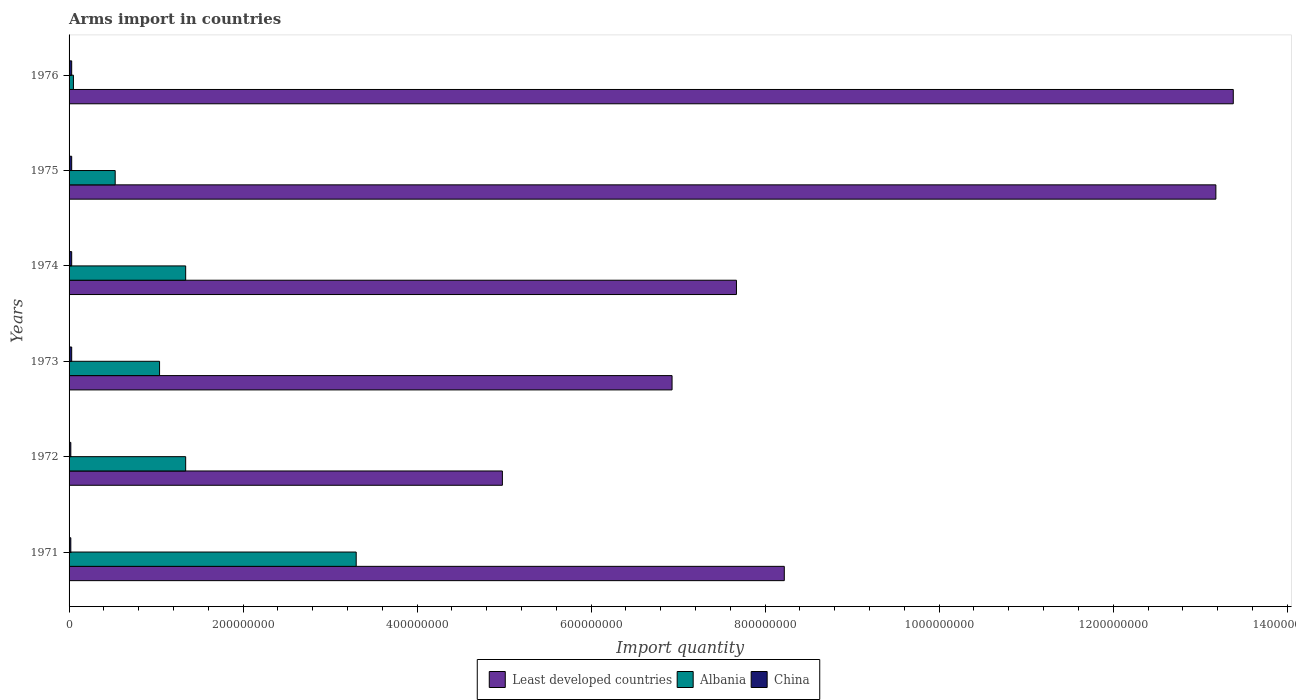Are the number of bars per tick equal to the number of legend labels?
Make the answer very short. Yes. How many bars are there on the 4th tick from the top?
Give a very brief answer. 3. How many bars are there on the 6th tick from the bottom?
Offer a very short reply. 3. What is the label of the 3rd group of bars from the top?
Offer a terse response. 1974. In how many cases, is the number of bars for a given year not equal to the number of legend labels?
Offer a very short reply. 0. What is the total arms import in Least developed countries in 1971?
Make the answer very short. 8.22e+08. Across all years, what is the maximum total arms import in Albania?
Keep it short and to the point. 3.30e+08. Across all years, what is the minimum total arms import in Albania?
Offer a terse response. 5.00e+06. In which year was the total arms import in China maximum?
Make the answer very short. 1973. In which year was the total arms import in Albania minimum?
Your answer should be very brief. 1976. What is the total total arms import in Least developed countries in the graph?
Provide a succinct answer. 5.44e+09. What is the difference between the total arms import in Least developed countries in 1971 and that in 1973?
Provide a succinct answer. 1.29e+08. What is the difference between the total arms import in Least developed countries in 1975 and the total arms import in China in 1974?
Offer a terse response. 1.32e+09. What is the average total arms import in Albania per year?
Ensure brevity in your answer.  1.27e+08. In the year 1971, what is the difference between the total arms import in China and total arms import in Albania?
Your answer should be compact. -3.28e+08. In how many years, is the total arms import in China greater than 1000000000 ?
Ensure brevity in your answer.  0. What is the ratio of the total arms import in Albania in 1972 to that in 1973?
Give a very brief answer. 1.29. What is the difference between the highest and the second highest total arms import in Albania?
Keep it short and to the point. 1.96e+08. What is the difference between the highest and the lowest total arms import in China?
Give a very brief answer. 1.00e+06. What does the 3rd bar from the top in 1976 represents?
Make the answer very short. Least developed countries. What does the 2nd bar from the bottom in 1974 represents?
Your answer should be compact. Albania. Is it the case that in every year, the sum of the total arms import in Least developed countries and total arms import in Albania is greater than the total arms import in China?
Keep it short and to the point. Yes. How many bars are there?
Offer a terse response. 18. Are all the bars in the graph horizontal?
Keep it short and to the point. Yes. What is the difference between two consecutive major ticks on the X-axis?
Provide a succinct answer. 2.00e+08. Does the graph contain any zero values?
Your answer should be compact. No. Does the graph contain grids?
Your answer should be compact. No. How many legend labels are there?
Ensure brevity in your answer.  3. What is the title of the graph?
Make the answer very short. Arms import in countries. What is the label or title of the X-axis?
Offer a terse response. Import quantity. What is the label or title of the Y-axis?
Offer a very short reply. Years. What is the Import quantity of Least developed countries in 1971?
Ensure brevity in your answer.  8.22e+08. What is the Import quantity of Albania in 1971?
Keep it short and to the point. 3.30e+08. What is the Import quantity of Least developed countries in 1972?
Give a very brief answer. 4.98e+08. What is the Import quantity of Albania in 1972?
Your response must be concise. 1.34e+08. What is the Import quantity of China in 1972?
Provide a short and direct response. 2.00e+06. What is the Import quantity of Least developed countries in 1973?
Provide a succinct answer. 6.93e+08. What is the Import quantity of Albania in 1973?
Provide a short and direct response. 1.04e+08. What is the Import quantity in China in 1973?
Keep it short and to the point. 3.00e+06. What is the Import quantity in Least developed countries in 1974?
Offer a very short reply. 7.67e+08. What is the Import quantity in Albania in 1974?
Offer a terse response. 1.34e+08. What is the Import quantity in Least developed countries in 1975?
Offer a terse response. 1.32e+09. What is the Import quantity of Albania in 1975?
Provide a short and direct response. 5.30e+07. What is the Import quantity in Least developed countries in 1976?
Your answer should be compact. 1.34e+09. What is the Import quantity in China in 1976?
Your answer should be very brief. 3.00e+06. Across all years, what is the maximum Import quantity of Least developed countries?
Your answer should be very brief. 1.34e+09. Across all years, what is the maximum Import quantity in Albania?
Your answer should be compact. 3.30e+08. Across all years, what is the minimum Import quantity of Least developed countries?
Your answer should be very brief. 4.98e+08. Across all years, what is the minimum Import quantity of Albania?
Make the answer very short. 5.00e+06. Across all years, what is the minimum Import quantity of China?
Your answer should be compact. 2.00e+06. What is the total Import quantity of Least developed countries in the graph?
Your response must be concise. 5.44e+09. What is the total Import quantity of Albania in the graph?
Give a very brief answer. 7.60e+08. What is the total Import quantity of China in the graph?
Provide a short and direct response. 1.60e+07. What is the difference between the Import quantity of Least developed countries in 1971 and that in 1972?
Make the answer very short. 3.24e+08. What is the difference between the Import quantity in Albania in 1971 and that in 1972?
Give a very brief answer. 1.96e+08. What is the difference between the Import quantity in Least developed countries in 1971 and that in 1973?
Ensure brevity in your answer.  1.29e+08. What is the difference between the Import quantity in Albania in 1971 and that in 1973?
Give a very brief answer. 2.26e+08. What is the difference between the Import quantity of Least developed countries in 1971 and that in 1974?
Offer a terse response. 5.50e+07. What is the difference between the Import quantity of Albania in 1971 and that in 1974?
Give a very brief answer. 1.96e+08. What is the difference between the Import quantity in Least developed countries in 1971 and that in 1975?
Your answer should be very brief. -4.96e+08. What is the difference between the Import quantity of Albania in 1971 and that in 1975?
Provide a succinct answer. 2.77e+08. What is the difference between the Import quantity in Least developed countries in 1971 and that in 1976?
Provide a short and direct response. -5.16e+08. What is the difference between the Import quantity of Albania in 1971 and that in 1976?
Keep it short and to the point. 3.25e+08. What is the difference between the Import quantity of Least developed countries in 1972 and that in 1973?
Ensure brevity in your answer.  -1.95e+08. What is the difference between the Import quantity in Albania in 1972 and that in 1973?
Make the answer very short. 3.00e+07. What is the difference between the Import quantity of China in 1972 and that in 1973?
Keep it short and to the point. -1.00e+06. What is the difference between the Import quantity of Least developed countries in 1972 and that in 1974?
Keep it short and to the point. -2.69e+08. What is the difference between the Import quantity of Albania in 1972 and that in 1974?
Provide a succinct answer. 0. What is the difference between the Import quantity of China in 1972 and that in 1974?
Your answer should be very brief. -1.00e+06. What is the difference between the Import quantity in Least developed countries in 1972 and that in 1975?
Provide a short and direct response. -8.20e+08. What is the difference between the Import quantity of Albania in 1972 and that in 1975?
Your response must be concise. 8.10e+07. What is the difference between the Import quantity of Least developed countries in 1972 and that in 1976?
Give a very brief answer. -8.40e+08. What is the difference between the Import quantity of Albania in 1972 and that in 1976?
Your response must be concise. 1.29e+08. What is the difference between the Import quantity in China in 1972 and that in 1976?
Provide a short and direct response. -1.00e+06. What is the difference between the Import quantity in Least developed countries in 1973 and that in 1974?
Ensure brevity in your answer.  -7.40e+07. What is the difference between the Import quantity in Albania in 1973 and that in 1974?
Your answer should be very brief. -3.00e+07. What is the difference between the Import quantity in China in 1973 and that in 1974?
Your answer should be compact. 0. What is the difference between the Import quantity of Least developed countries in 1973 and that in 1975?
Give a very brief answer. -6.25e+08. What is the difference between the Import quantity of Albania in 1973 and that in 1975?
Keep it short and to the point. 5.10e+07. What is the difference between the Import quantity in China in 1973 and that in 1975?
Ensure brevity in your answer.  0. What is the difference between the Import quantity in Least developed countries in 1973 and that in 1976?
Your response must be concise. -6.45e+08. What is the difference between the Import quantity in Albania in 1973 and that in 1976?
Offer a very short reply. 9.90e+07. What is the difference between the Import quantity in Least developed countries in 1974 and that in 1975?
Your answer should be compact. -5.51e+08. What is the difference between the Import quantity in Albania in 1974 and that in 1975?
Your response must be concise. 8.10e+07. What is the difference between the Import quantity of China in 1974 and that in 1975?
Provide a short and direct response. 0. What is the difference between the Import quantity in Least developed countries in 1974 and that in 1976?
Keep it short and to the point. -5.71e+08. What is the difference between the Import quantity of Albania in 1974 and that in 1976?
Make the answer very short. 1.29e+08. What is the difference between the Import quantity in China in 1974 and that in 1976?
Provide a short and direct response. 0. What is the difference between the Import quantity in Least developed countries in 1975 and that in 1976?
Offer a terse response. -2.00e+07. What is the difference between the Import quantity of Albania in 1975 and that in 1976?
Make the answer very short. 4.80e+07. What is the difference between the Import quantity in Least developed countries in 1971 and the Import quantity in Albania in 1972?
Provide a short and direct response. 6.88e+08. What is the difference between the Import quantity in Least developed countries in 1971 and the Import quantity in China in 1972?
Your answer should be very brief. 8.20e+08. What is the difference between the Import quantity in Albania in 1971 and the Import quantity in China in 1972?
Keep it short and to the point. 3.28e+08. What is the difference between the Import quantity in Least developed countries in 1971 and the Import quantity in Albania in 1973?
Your answer should be compact. 7.18e+08. What is the difference between the Import quantity of Least developed countries in 1971 and the Import quantity of China in 1973?
Provide a succinct answer. 8.19e+08. What is the difference between the Import quantity in Albania in 1971 and the Import quantity in China in 1973?
Give a very brief answer. 3.27e+08. What is the difference between the Import quantity of Least developed countries in 1971 and the Import quantity of Albania in 1974?
Your answer should be compact. 6.88e+08. What is the difference between the Import quantity in Least developed countries in 1971 and the Import quantity in China in 1974?
Ensure brevity in your answer.  8.19e+08. What is the difference between the Import quantity of Albania in 1971 and the Import quantity of China in 1974?
Make the answer very short. 3.27e+08. What is the difference between the Import quantity of Least developed countries in 1971 and the Import quantity of Albania in 1975?
Your answer should be very brief. 7.69e+08. What is the difference between the Import quantity of Least developed countries in 1971 and the Import quantity of China in 1975?
Ensure brevity in your answer.  8.19e+08. What is the difference between the Import quantity in Albania in 1971 and the Import quantity in China in 1975?
Provide a succinct answer. 3.27e+08. What is the difference between the Import quantity of Least developed countries in 1971 and the Import quantity of Albania in 1976?
Offer a very short reply. 8.17e+08. What is the difference between the Import quantity in Least developed countries in 1971 and the Import quantity in China in 1976?
Make the answer very short. 8.19e+08. What is the difference between the Import quantity in Albania in 1971 and the Import quantity in China in 1976?
Your answer should be compact. 3.27e+08. What is the difference between the Import quantity in Least developed countries in 1972 and the Import quantity in Albania in 1973?
Offer a terse response. 3.94e+08. What is the difference between the Import quantity in Least developed countries in 1972 and the Import quantity in China in 1973?
Your answer should be very brief. 4.95e+08. What is the difference between the Import quantity of Albania in 1972 and the Import quantity of China in 1973?
Ensure brevity in your answer.  1.31e+08. What is the difference between the Import quantity of Least developed countries in 1972 and the Import quantity of Albania in 1974?
Your answer should be compact. 3.64e+08. What is the difference between the Import quantity of Least developed countries in 1972 and the Import quantity of China in 1974?
Your answer should be very brief. 4.95e+08. What is the difference between the Import quantity of Albania in 1972 and the Import quantity of China in 1974?
Provide a succinct answer. 1.31e+08. What is the difference between the Import quantity in Least developed countries in 1972 and the Import quantity in Albania in 1975?
Your answer should be compact. 4.45e+08. What is the difference between the Import quantity in Least developed countries in 1972 and the Import quantity in China in 1975?
Provide a succinct answer. 4.95e+08. What is the difference between the Import quantity of Albania in 1972 and the Import quantity of China in 1975?
Keep it short and to the point. 1.31e+08. What is the difference between the Import quantity in Least developed countries in 1972 and the Import quantity in Albania in 1976?
Your response must be concise. 4.93e+08. What is the difference between the Import quantity of Least developed countries in 1972 and the Import quantity of China in 1976?
Offer a very short reply. 4.95e+08. What is the difference between the Import quantity of Albania in 1972 and the Import quantity of China in 1976?
Your response must be concise. 1.31e+08. What is the difference between the Import quantity in Least developed countries in 1973 and the Import quantity in Albania in 1974?
Make the answer very short. 5.59e+08. What is the difference between the Import quantity in Least developed countries in 1973 and the Import quantity in China in 1974?
Offer a very short reply. 6.90e+08. What is the difference between the Import quantity in Albania in 1973 and the Import quantity in China in 1974?
Offer a terse response. 1.01e+08. What is the difference between the Import quantity in Least developed countries in 1973 and the Import quantity in Albania in 1975?
Make the answer very short. 6.40e+08. What is the difference between the Import quantity in Least developed countries in 1973 and the Import quantity in China in 1975?
Provide a succinct answer. 6.90e+08. What is the difference between the Import quantity in Albania in 1973 and the Import quantity in China in 1975?
Your answer should be compact. 1.01e+08. What is the difference between the Import quantity in Least developed countries in 1973 and the Import quantity in Albania in 1976?
Provide a succinct answer. 6.88e+08. What is the difference between the Import quantity of Least developed countries in 1973 and the Import quantity of China in 1976?
Your answer should be compact. 6.90e+08. What is the difference between the Import quantity in Albania in 1973 and the Import quantity in China in 1976?
Your answer should be very brief. 1.01e+08. What is the difference between the Import quantity in Least developed countries in 1974 and the Import quantity in Albania in 1975?
Provide a succinct answer. 7.14e+08. What is the difference between the Import quantity in Least developed countries in 1974 and the Import quantity in China in 1975?
Offer a very short reply. 7.64e+08. What is the difference between the Import quantity of Albania in 1974 and the Import quantity of China in 1975?
Provide a succinct answer. 1.31e+08. What is the difference between the Import quantity of Least developed countries in 1974 and the Import quantity of Albania in 1976?
Your answer should be compact. 7.62e+08. What is the difference between the Import quantity of Least developed countries in 1974 and the Import quantity of China in 1976?
Your answer should be very brief. 7.64e+08. What is the difference between the Import quantity in Albania in 1974 and the Import quantity in China in 1976?
Keep it short and to the point. 1.31e+08. What is the difference between the Import quantity in Least developed countries in 1975 and the Import quantity in Albania in 1976?
Ensure brevity in your answer.  1.31e+09. What is the difference between the Import quantity in Least developed countries in 1975 and the Import quantity in China in 1976?
Offer a very short reply. 1.32e+09. What is the average Import quantity in Least developed countries per year?
Your answer should be very brief. 9.06e+08. What is the average Import quantity of Albania per year?
Offer a very short reply. 1.27e+08. What is the average Import quantity of China per year?
Ensure brevity in your answer.  2.67e+06. In the year 1971, what is the difference between the Import quantity of Least developed countries and Import quantity of Albania?
Offer a very short reply. 4.92e+08. In the year 1971, what is the difference between the Import quantity of Least developed countries and Import quantity of China?
Your response must be concise. 8.20e+08. In the year 1971, what is the difference between the Import quantity of Albania and Import quantity of China?
Your answer should be very brief. 3.28e+08. In the year 1972, what is the difference between the Import quantity of Least developed countries and Import quantity of Albania?
Your answer should be very brief. 3.64e+08. In the year 1972, what is the difference between the Import quantity in Least developed countries and Import quantity in China?
Ensure brevity in your answer.  4.96e+08. In the year 1972, what is the difference between the Import quantity of Albania and Import quantity of China?
Ensure brevity in your answer.  1.32e+08. In the year 1973, what is the difference between the Import quantity of Least developed countries and Import quantity of Albania?
Offer a terse response. 5.89e+08. In the year 1973, what is the difference between the Import quantity of Least developed countries and Import quantity of China?
Ensure brevity in your answer.  6.90e+08. In the year 1973, what is the difference between the Import quantity in Albania and Import quantity in China?
Offer a very short reply. 1.01e+08. In the year 1974, what is the difference between the Import quantity in Least developed countries and Import quantity in Albania?
Ensure brevity in your answer.  6.33e+08. In the year 1974, what is the difference between the Import quantity in Least developed countries and Import quantity in China?
Your answer should be compact. 7.64e+08. In the year 1974, what is the difference between the Import quantity in Albania and Import quantity in China?
Offer a terse response. 1.31e+08. In the year 1975, what is the difference between the Import quantity of Least developed countries and Import quantity of Albania?
Provide a short and direct response. 1.26e+09. In the year 1975, what is the difference between the Import quantity in Least developed countries and Import quantity in China?
Keep it short and to the point. 1.32e+09. In the year 1976, what is the difference between the Import quantity of Least developed countries and Import quantity of Albania?
Provide a succinct answer. 1.33e+09. In the year 1976, what is the difference between the Import quantity in Least developed countries and Import quantity in China?
Provide a short and direct response. 1.34e+09. In the year 1976, what is the difference between the Import quantity of Albania and Import quantity of China?
Make the answer very short. 2.00e+06. What is the ratio of the Import quantity in Least developed countries in 1971 to that in 1972?
Provide a succinct answer. 1.65. What is the ratio of the Import quantity of Albania in 1971 to that in 1972?
Keep it short and to the point. 2.46. What is the ratio of the Import quantity in China in 1971 to that in 1972?
Ensure brevity in your answer.  1. What is the ratio of the Import quantity in Least developed countries in 1971 to that in 1973?
Provide a short and direct response. 1.19. What is the ratio of the Import quantity in Albania in 1971 to that in 1973?
Provide a short and direct response. 3.17. What is the ratio of the Import quantity in China in 1971 to that in 1973?
Keep it short and to the point. 0.67. What is the ratio of the Import quantity of Least developed countries in 1971 to that in 1974?
Provide a short and direct response. 1.07. What is the ratio of the Import quantity in Albania in 1971 to that in 1974?
Your answer should be compact. 2.46. What is the ratio of the Import quantity in China in 1971 to that in 1974?
Your response must be concise. 0.67. What is the ratio of the Import quantity of Least developed countries in 1971 to that in 1975?
Provide a succinct answer. 0.62. What is the ratio of the Import quantity in Albania in 1971 to that in 1975?
Your response must be concise. 6.23. What is the ratio of the Import quantity of China in 1971 to that in 1975?
Ensure brevity in your answer.  0.67. What is the ratio of the Import quantity of Least developed countries in 1971 to that in 1976?
Your response must be concise. 0.61. What is the ratio of the Import quantity in Least developed countries in 1972 to that in 1973?
Give a very brief answer. 0.72. What is the ratio of the Import quantity of Albania in 1972 to that in 1973?
Keep it short and to the point. 1.29. What is the ratio of the Import quantity in China in 1972 to that in 1973?
Your answer should be compact. 0.67. What is the ratio of the Import quantity in Least developed countries in 1972 to that in 1974?
Provide a succinct answer. 0.65. What is the ratio of the Import quantity in Albania in 1972 to that in 1974?
Give a very brief answer. 1. What is the ratio of the Import quantity of China in 1972 to that in 1974?
Provide a succinct answer. 0.67. What is the ratio of the Import quantity of Least developed countries in 1972 to that in 1975?
Your answer should be compact. 0.38. What is the ratio of the Import quantity of Albania in 1972 to that in 1975?
Offer a very short reply. 2.53. What is the ratio of the Import quantity in China in 1972 to that in 1975?
Offer a very short reply. 0.67. What is the ratio of the Import quantity in Least developed countries in 1972 to that in 1976?
Give a very brief answer. 0.37. What is the ratio of the Import quantity in Albania in 1972 to that in 1976?
Your answer should be compact. 26.8. What is the ratio of the Import quantity of Least developed countries in 1973 to that in 1974?
Give a very brief answer. 0.9. What is the ratio of the Import quantity of Albania in 1973 to that in 1974?
Your response must be concise. 0.78. What is the ratio of the Import quantity of China in 1973 to that in 1974?
Your answer should be compact. 1. What is the ratio of the Import quantity in Least developed countries in 1973 to that in 1975?
Make the answer very short. 0.53. What is the ratio of the Import quantity of Albania in 1973 to that in 1975?
Give a very brief answer. 1.96. What is the ratio of the Import quantity of China in 1973 to that in 1975?
Ensure brevity in your answer.  1. What is the ratio of the Import quantity of Least developed countries in 1973 to that in 1976?
Provide a succinct answer. 0.52. What is the ratio of the Import quantity in Albania in 1973 to that in 1976?
Offer a very short reply. 20.8. What is the ratio of the Import quantity of China in 1973 to that in 1976?
Your response must be concise. 1. What is the ratio of the Import quantity of Least developed countries in 1974 to that in 1975?
Your answer should be very brief. 0.58. What is the ratio of the Import quantity in Albania in 1974 to that in 1975?
Provide a short and direct response. 2.53. What is the ratio of the Import quantity in China in 1974 to that in 1975?
Keep it short and to the point. 1. What is the ratio of the Import quantity in Least developed countries in 1974 to that in 1976?
Make the answer very short. 0.57. What is the ratio of the Import quantity of Albania in 1974 to that in 1976?
Offer a very short reply. 26.8. What is the ratio of the Import quantity in Least developed countries in 1975 to that in 1976?
Your response must be concise. 0.99. What is the ratio of the Import quantity in Albania in 1975 to that in 1976?
Make the answer very short. 10.6. What is the difference between the highest and the second highest Import quantity of Albania?
Ensure brevity in your answer.  1.96e+08. What is the difference between the highest and the lowest Import quantity in Least developed countries?
Your response must be concise. 8.40e+08. What is the difference between the highest and the lowest Import quantity in Albania?
Keep it short and to the point. 3.25e+08. 